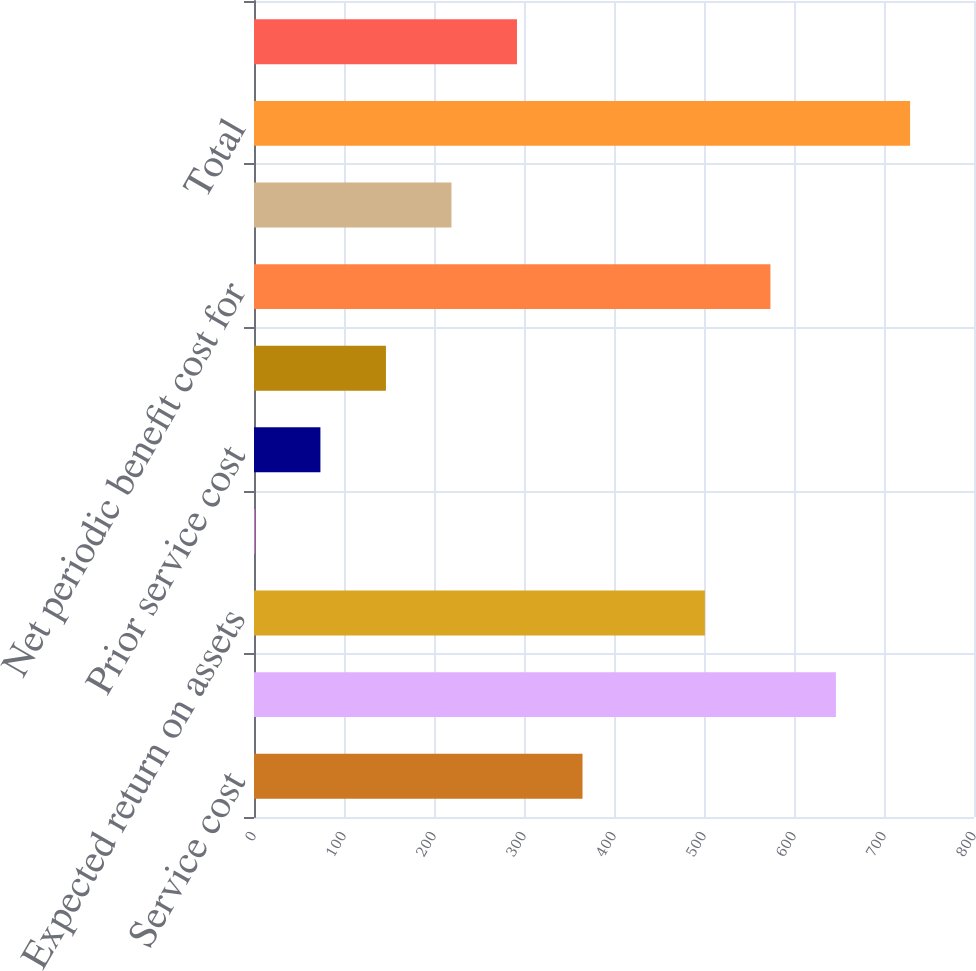Convert chart. <chart><loc_0><loc_0><loc_500><loc_500><bar_chart><fcel>Service cost<fcel>Interest cost<fcel>Expected return on assets<fcel>Transition asset<fcel>Prior service cost<fcel>Unrecognized net loss<fcel>Net periodic benefit cost for<fcel>Defined contribution plans<fcel>Total<fcel>Net periodic benefit cost<nl><fcel>365<fcel>646.6<fcel>501<fcel>1<fcel>73.8<fcel>146.6<fcel>573.8<fcel>219.4<fcel>729<fcel>292.2<nl></chart> 